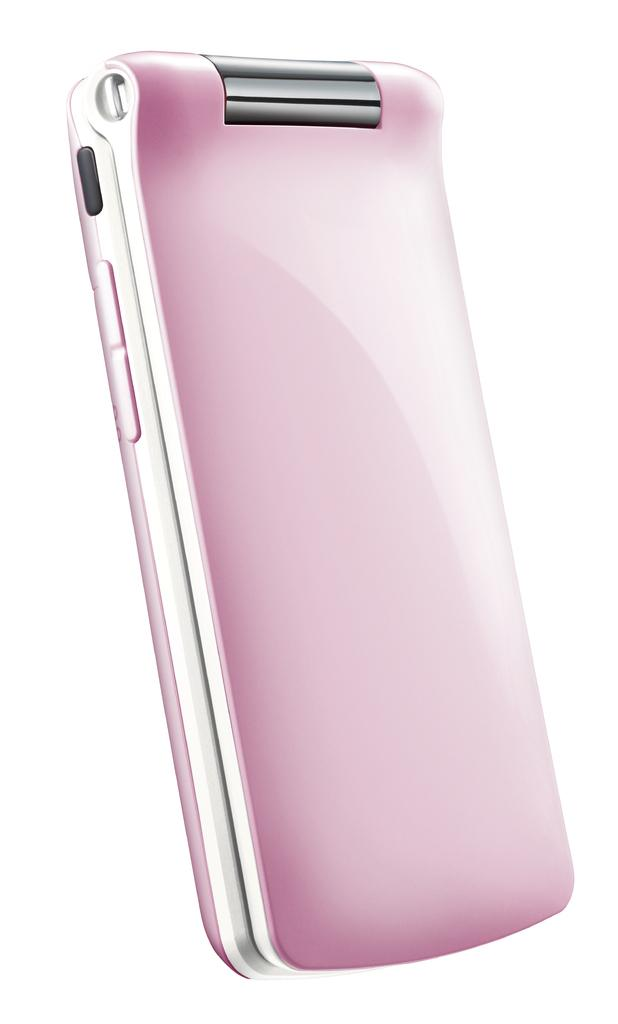What is the main subject in the center of the image? There is a mobile in the center of the image. What type of whip can be seen in the cemetery in the image? There is no whip or cemetery present in the image; it only features a mobile in the center. 